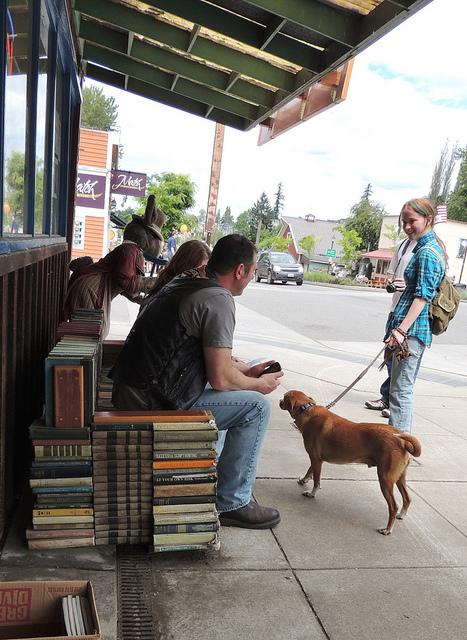From which room could items used to make this chair originate? Please explain your reasoning. library. The room is the library. 